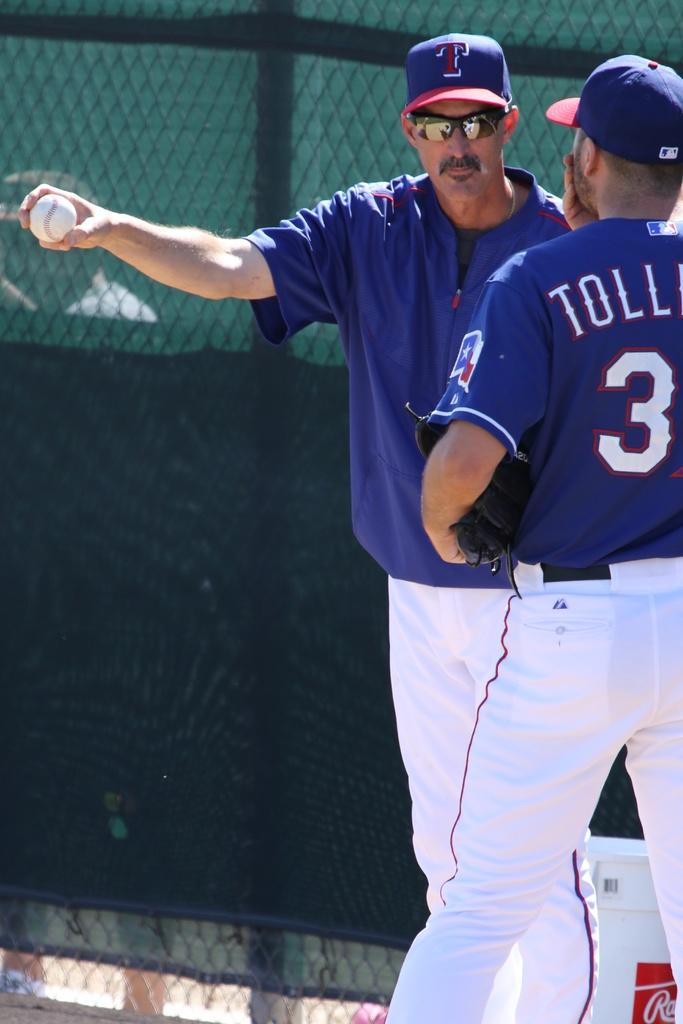How many people are in the image? There are two persons in the image. What are the two persons wearing? Both persons are wearing the same dress and caps. What is one of the persons holding in his hand? One of the persons is holding a ball in his hand. What can be seen behind the two persons? There is a net behind the two persons. What type of produce is being harvested by the two persons in the image? There is no produce being harvested in the image; the two persons are wearing the same dress and caps, one is holding a ball, and there is a net behind them. 